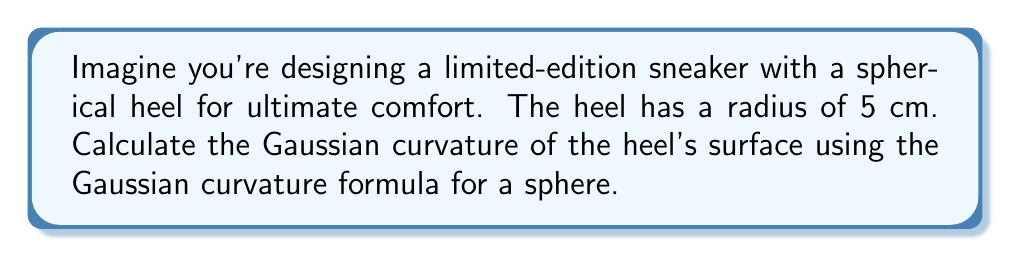Can you answer this question? Let's approach this step-by-step:

1) The Gaussian curvature formula for a sphere is:

   $$K = \frac{1}{R^2}$$

   where $K$ is the Gaussian curvature and $R$ is the radius of the sphere.

2) In this case, we're given that the radius of the spherical heel is 5 cm.

3) Let's substitute this into our formula:

   $$K = \frac{1}{(5\text{ cm})^2}$$

4) Simplify:
   
   $$K = \frac{1}{25\text{ cm}^2}$$

5) This can be expressed as:

   $$K = 0.04\text{ cm}^{-2}$$

Note: The units of Gaussian curvature are always the inverse square of the length unit used.
Answer: $0.04\text{ cm}^{-2}$ 